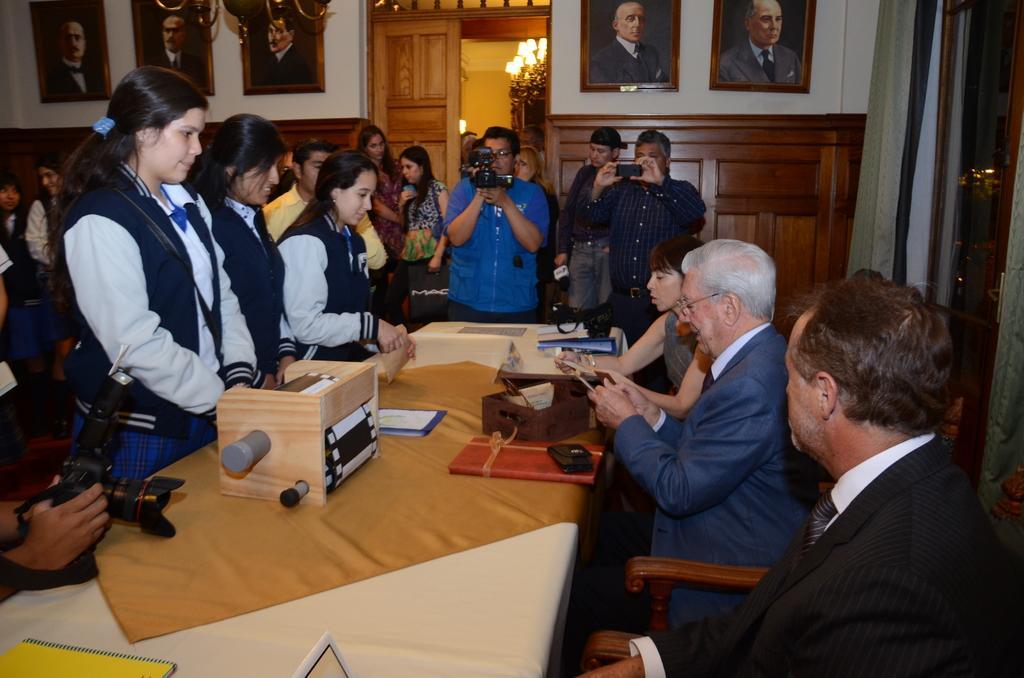Could you give a brief overview of what you see in this image? In this image i can see few people some are standing and some are sitting there are few files, some papers and a cart board on a table at the back ground i can see few frames attached to a wall ,a door and a light. 